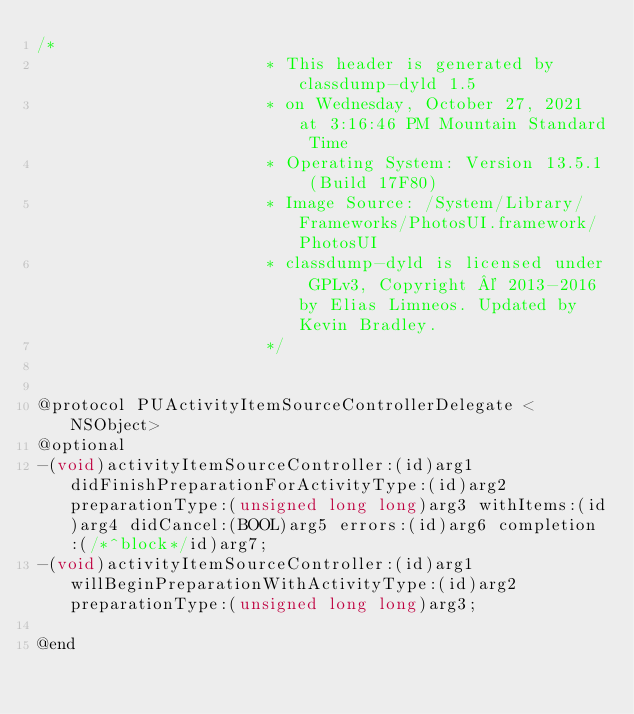<code> <loc_0><loc_0><loc_500><loc_500><_C_>/*
                       * This header is generated by classdump-dyld 1.5
                       * on Wednesday, October 27, 2021 at 3:16:46 PM Mountain Standard Time
                       * Operating System: Version 13.5.1 (Build 17F80)
                       * Image Source: /System/Library/Frameworks/PhotosUI.framework/PhotosUI
                       * classdump-dyld is licensed under GPLv3, Copyright © 2013-2016 by Elias Limneos. Updated by Kevin Bradley.
                       */


@protocol PUActivityItemSourceControllerDelegate <NSObject>
@optional
-(void)activityItemSourceController:(id)arg1 didFinishPreparationForActivityType:(id)arg2 preparationType:(unsigned long long)arg3 withItems:(id)arg4 didCancel:(BOOL)arg5 errors:(id)arg6 completion:(/*^block*/id)arg7;
-(void)activityItemSourceController:(id)arg1 willBeginPreparationWithActivityType:(id)arg2 preparationType:(unsigned long long)arg3;

@end

</code> 